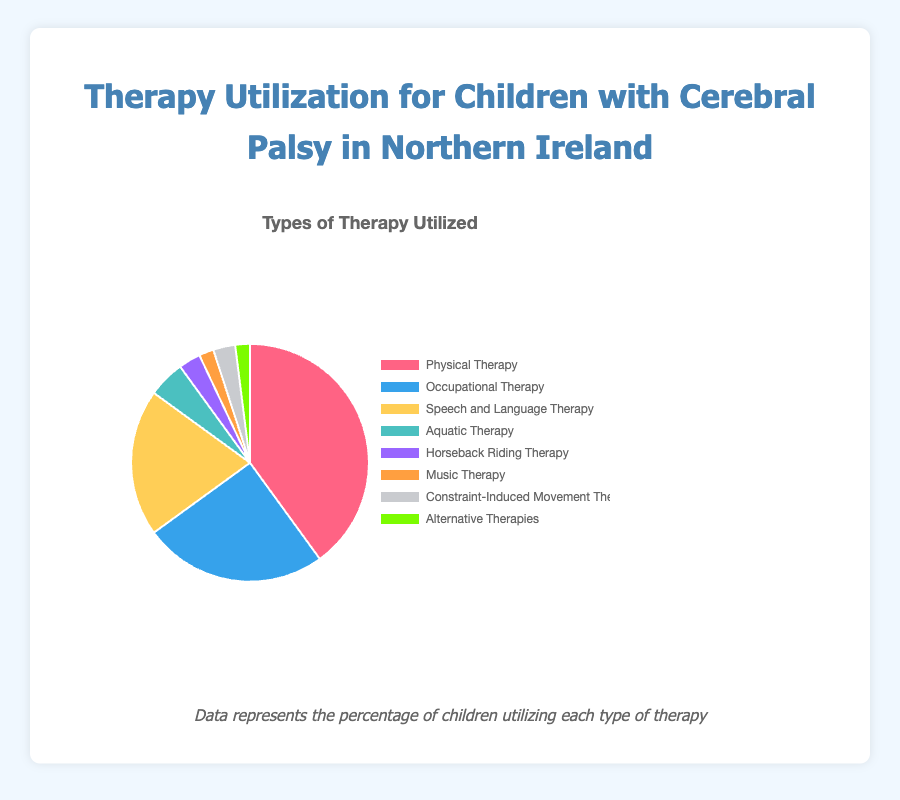What type of therapy is most utilized by children with cerebral palsy in Northern Ireland? The figure shows a pie chart with different percentages for various therapies. The largest slice represents Physical Therapy with 40%.
Answer: Physical Therapy Which therapy is utilized more, Occupational Therapy or Speech and Language Therapy? Occupational Therapy has a percentage of 25%, while Speech and Language Therapy has 20%. Comparing these, Occupational Therapy is utilized more.
Answer: Occupational Therapy What is the combined percentage of children using Horseback Riding Therapy and Constraint-Induced Movement Therapy? The percentage for Horseback Riding Therapy is 3% and for Constraint-Induced Movement Therapy is also 3%. Adding these gives 3% + 3% = 6%.
Answer: 6% Which therapy has the smallest utilization percentage, and what is it? The smallest slice on the pie chart represents the therapy with the smallest utilization percentage. Music Therapy and Alternative Therapies both have the smallest percentages at 2% each.
Answer: Music Therapy and Alternative Therapies How much more is the utilization of Physical Therapy compared to Aquatic Therapy? Physical Therapy utilization is 40%, and Aquatic Therapy is 5%. Subtracting these gives 40% - 5% = 35%.
Answer: 35% What is the total percentage of children utilizing Physical Therapy, Occupational Therapy, and Speech and Language Therapy? The percentages are 40% for Physical Therapy, 25% for Occupational Therapy, and 20% for Speech and Language Therapy. Summing these gives 40% + 25% + 20% = 85%.
Answer: 85% If you combine all therapies except Physical Therapy, what is their total utilization percentage? Excluding Physical Therapy at 40%, the percentages for other therapies are 25%, 20%, 5%, 3%, 2%, 3%, and 2%. Summing these gives 25% + 20% + 5% + 3% + 2% + 3% + 2% = 60%.
Answer: 60% Between Constraint-Induced Movement Therapy and Alternative Therapy, which is utilized more and by how much? Constraint-Induced Movement Therapy has 3%, and Alternative Therapies have 2%. The difference is 3% - 2% = 1%.
Answer: Constraint-Induced Movement Therapy by 1% What is the average utilization percentage of Aquatic Therapy, Horseback Riding Therapy, and Music Therapy? The percentages are 5% for Aquatic Therapy, 3% for Horseback Riding Therapy, and 2% for Music Therapy. The sum is 5% + 3% + 2% = 10%, and the average is 10% / 3 ≈ 3.33%.
Answer: 3.33% Which slice in the pie chart is represented by the color blue? The color blue represents Occupational Therapy in the pie chart.
Answer: Occupational Therapy 